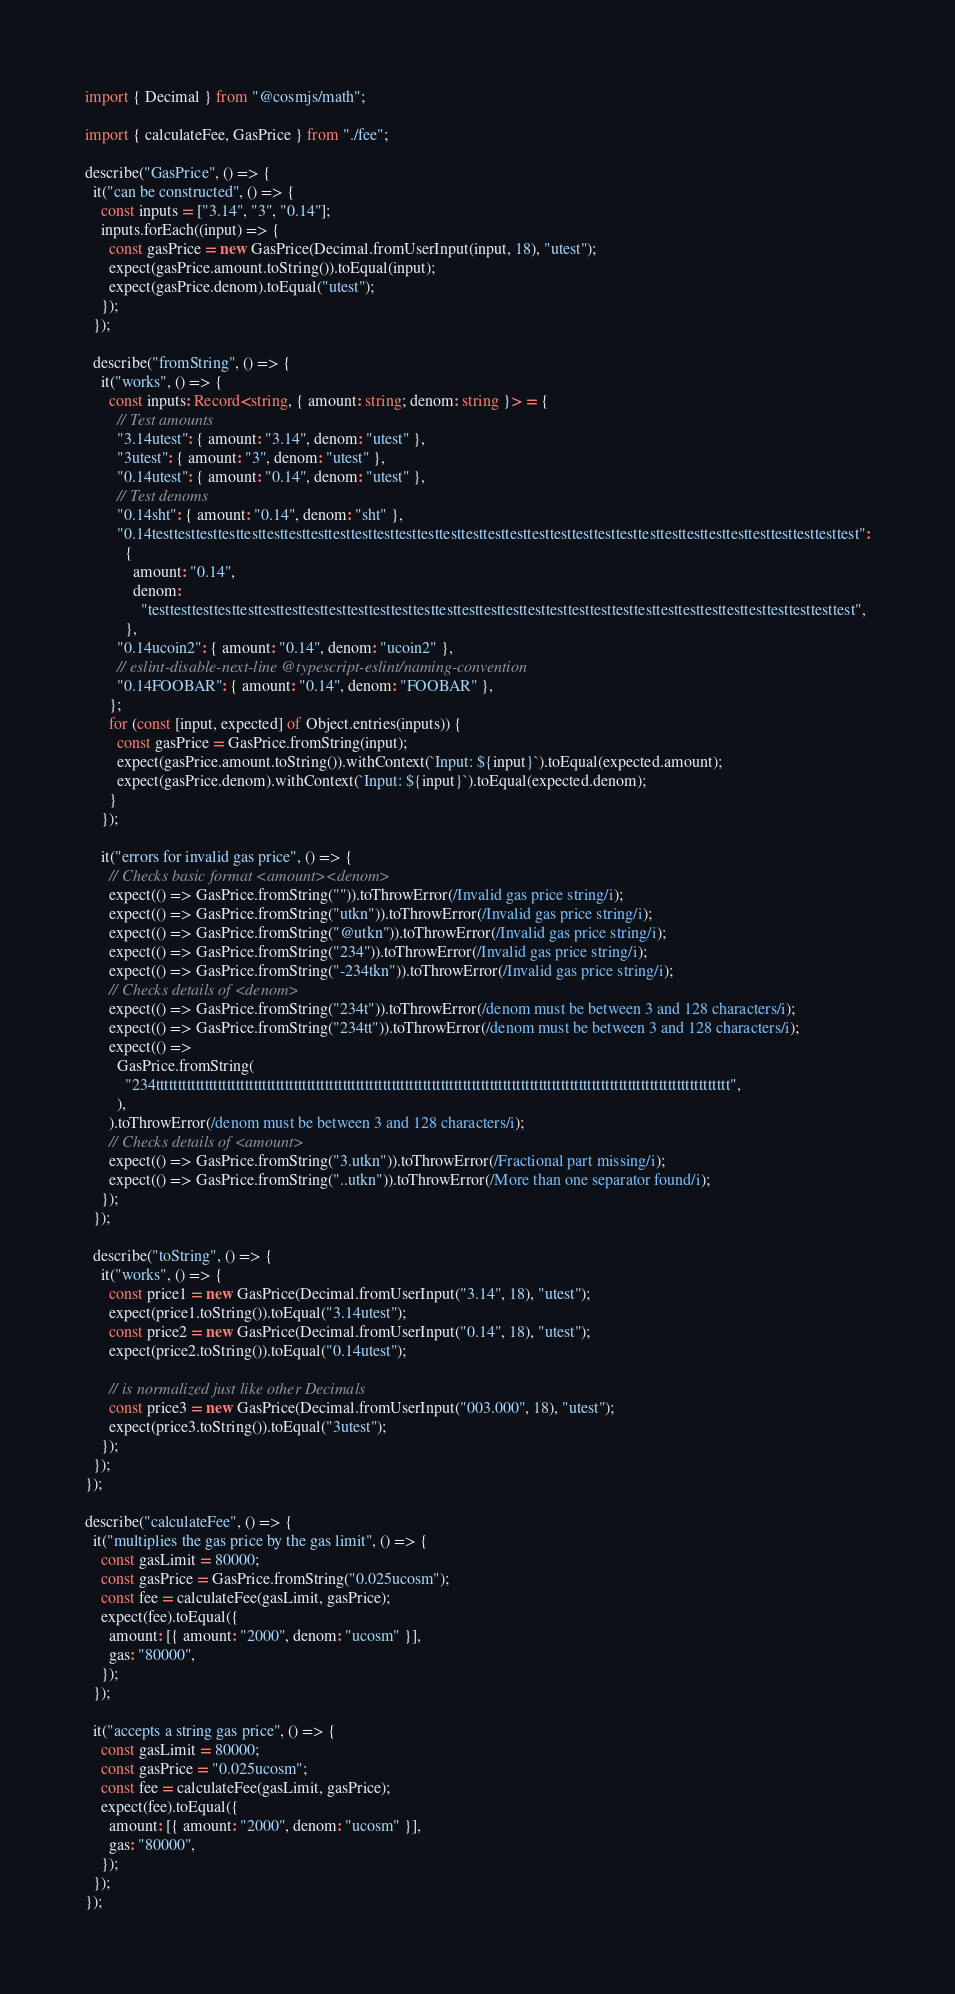Convert code to text. <code><loc_0><loc_0><loc_500><loc_500><_TypeScript_>import { Decimal } from "@cosmjs/math";

import { calculateFee, GasPrice } from "./fee";

describe("GasPrice", () => {
  it("can be constructed", () => {
    const inputs = ["3.14", "3", "0.14"];
    inputs.forEach((input) => {
      const gasPrice = new GasPrice(Decimal.fromUserInput(input, 18), "utest");
      expect(gasPrice.amount.toString()).toEqual(input);
      expect(gasPrice.denom).toEqual("utest");
    });
  });

  describe("fromString", () => {
    it("works", () => {
      const inputs: Record<string, { amount: string; denom: string }> = {
        // Test amounts
        "3.14utest": { amount: "3.14", denom: "utest" },
        "3utest": { amount: "3", denom: "utest" },
        "0.14utest": { amount: "0.14", denom: "utest" },
        // Test denoms
        "0.14sht": { amount: "0.14", denom: "sht" },
        "0.14testtesttesttesttesttesttesttesttesttesttesttesttesttesttesttesttesttesttesttesttesttesttesttesttesttesttesttesttesttesttesttest":
          {
            amount: "0.14",
            denom:
              "testtesttesttesttesttesttesttesttesttesttesttesttesttesttesttesttesttesttesttesttesttesttesttesttesttesttesttesttesttesttesttest",
          },
        "0.14ucoin2": { amount: "0.14", denom: "ucoin2" },
        // eslint-disable-next-line @typescript-eslint/naming-convention
        "0.14FOOBAR": { amount: "0.14", denom: "FOOBAR" },
      };
      for (const [input, expected] of Object.entries(inputs)) {
        const gasPrice = GasPrice.fromString(input);
        expect(gasPrice.amount.toString()).withContext(`Input: ${input}`).toEqual(expected.amount);
        expect(gasPrice.denom).withContext(`Input: ${input}`).toEqual(expected.denom);
      }
    });

    it("errors for invalid gas price", () => {
      // Checks basic format <amount><denom>
      expect(() => GasPrice.fromString("")).toThrowError(/Invalid gas price string/i);
      expect(() => GasPrice.fromString("utkn")).toThrowError(/Invalid gas price string/i);
      expect(() => GasPrice.fromString("@utkn")).toThrowError(/Invalid gas price string/i);
      expect(() => GasPrice.fromString("234")).toThrowError(/Invalid gas price string/i);
      expect(() => GasPrice.fromString("-234tkn")).toThrowError(/Invalid gas price string/i);
      // Checks details of <denom>
      expect(() => GasPrice.fromString("234t")).toThrowError(/denom must be between 3 and 128 characters/i);
      expect(() => GasPrice.fromString("234tt")).toThrowError(/denom must be between 3 and 128 characters/i);
      expect(() =>
        GasPrice.fromString(
          "234ttttttttttttttttttttttttttttttttttttttttttttttttttttttttttttttttttttttttttttttttttttttttttttttttttttttttttttttttttttttttttttttttt",
        ),
      ).toThrowError(/denom must be between 3 and 128 characters/i);
      // Checks details of <amount>
      expect(() => GasPrice.fromString("3.utkn")).toThrowError(/Fractional part missing/i);
      expect(() => GasPrice.fromString("..utkn")).toThrowError(/More than one separator found/i);
    });
  });

  describe("toString", () => {
    it("works", () => {
      const price1 = new GasPrice(Decimal.fromUserInput("3.14", 18), "utest");
      expect(price1.toString()).toEqual("3.14utest");
      const price2 = new GasPrice(Decimal.fromUserInput("0.14", 18), "utest");
      expect(price2.toString()).toEqual("0.14utest");

      // is normalized just like other Decimals
      const price3 = new GasPrice(Decimal.fromUserInput("003.000", 18), "utest");
      expect(price3.toString()).toEqual("3utest");
    });
  });
});

describe("calculateFee", () => {
  it("multiplies the gas price by the gas limit", () => {
    const gasLimit = 80000;
    const gasPrice = GasPrice.fromString("0.025ucosm");
    const fee = calculateFee(gasLimit, gasPrice);
    expect(fee).toEqual({
      amount: [{ amount: "2000", denom: "ucosm" }],
      gas: "80000",
    });
  });

  it("accepts a string gas price", () => {
    const gasLimit = 80000;
    const gasPrice = "0.025ucosm";
    const fee = calculateFee(gasLimit, gasPrice);
    expect(fee).toEqual({
      amount: [{ amount: "2000", denom: "ucosm" }],
      gas: "80000",
    });
  });
});
</code> 